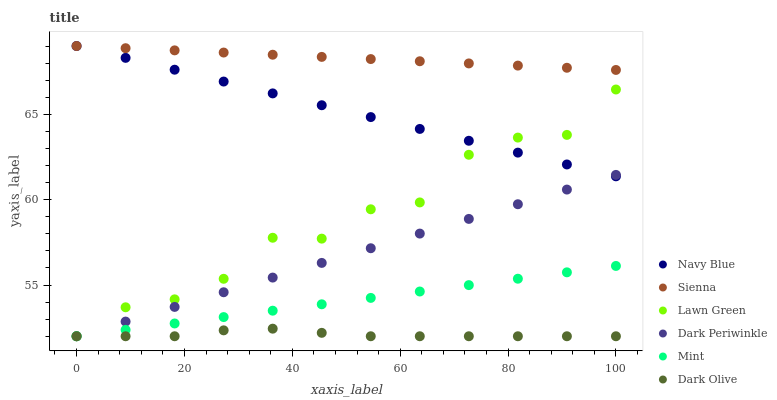Does Dark Olive have the minimum area under the curve?
Answer yes or no. Yes. Does Sienna have the maximum area under the curve?
Answer yes or no. Yes. Does Navy Blue have the minimum area under the curve?
Answer yes or no. No. Does Navy Blue have the maximum area under the curve?
Answer yes or no. No. Is Navy Blue the smoothest?
Answer yes or no. Yes. Is Lawn Green the roughest?
Answer yes or no. Yes. Is Dark Olive the smoothest?
Answer yes or no. No. Is Dark Olive the roughest?
Answer yes or no. No. Does Lawn Green have the lowest value?
Answer yes or no. Yes. Does Navy Blue have the lowest value?
Answer yes or no. No. Does Sienna have the highest value?
Answer yes or no. Yes. Does Dark Olive have the highest value?
Answer yes or no. No. Is Mint less than Sienna?
Answer yes or no. Yes. Is Sienna greater than Lawn Green?
Answer yes or no. Yes. Does Mint intersect Lawn Green?
Answer yes or no. Yes. Is Mint less than Lawn Green?
Answer yes or no. No. Is Mint greater than Lawn Green?
Answer yes or no. No. Does Mint intersect Sienna?
Answer yes or no. No. 